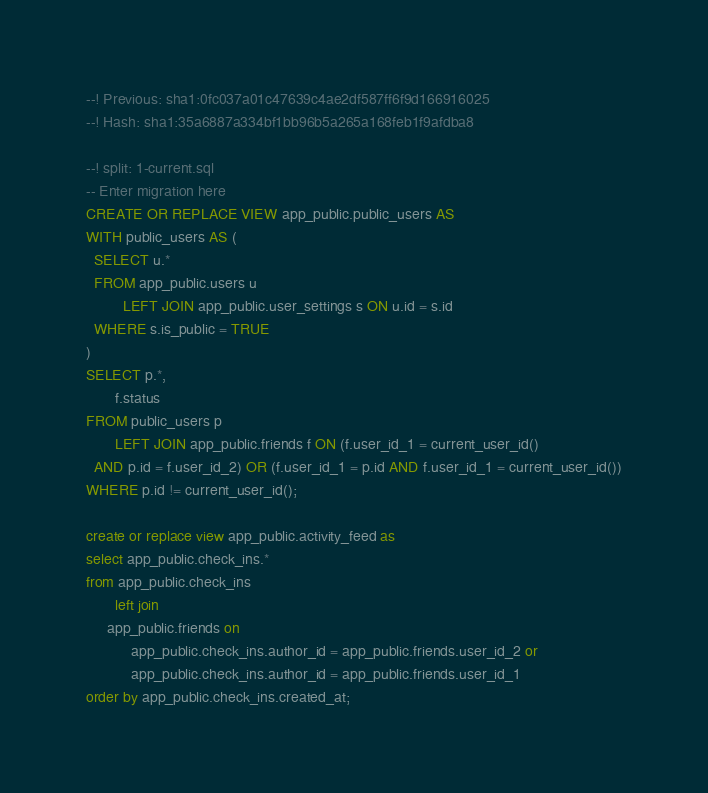<code> <loc_0><loc_0><loc_500><loc_500><_SQL_>--! Previous: sha1:0fc037a01c47639c4ae2df587ff6f9d166916025
--! Hash: sha1:35a6887a334bf1bb96b5a265a168feb1f9afdba8

--! split: 1-current.sql
-- Enter migration here
CREATE OR REPLACE VIEW app_public.public_users AS
WITH public_users AS (
  SELECT u.*
  FROM app_public.users u
         LEFT JOIN app_public.user_settings s ON u.id = s.id
  WHERE s.is_public = TRUE
)
SELECT p.*,
       f.status
FROM public_users p
       LEFT JOIN app_public.friends f ON (f.user_id_1 = current_user_id()
  AND p.id = f.user_id_2) OR (f.user_id_1 = p.id AND f.user_id_1 = current_user_id())
WHERE p.id != current_user_id();

create or replace view app_public.activity_feed as
select app_public.check_ins.*
from app_public.check_ins
       left join
     app_public.friends on
           app_public.check_ins.author_id = app_public.friends.user_id_2 or
           app_public.check_ins.author_id = app_public.friends.user_id_1
order by app_public.check_ins.created_at;
</code> 